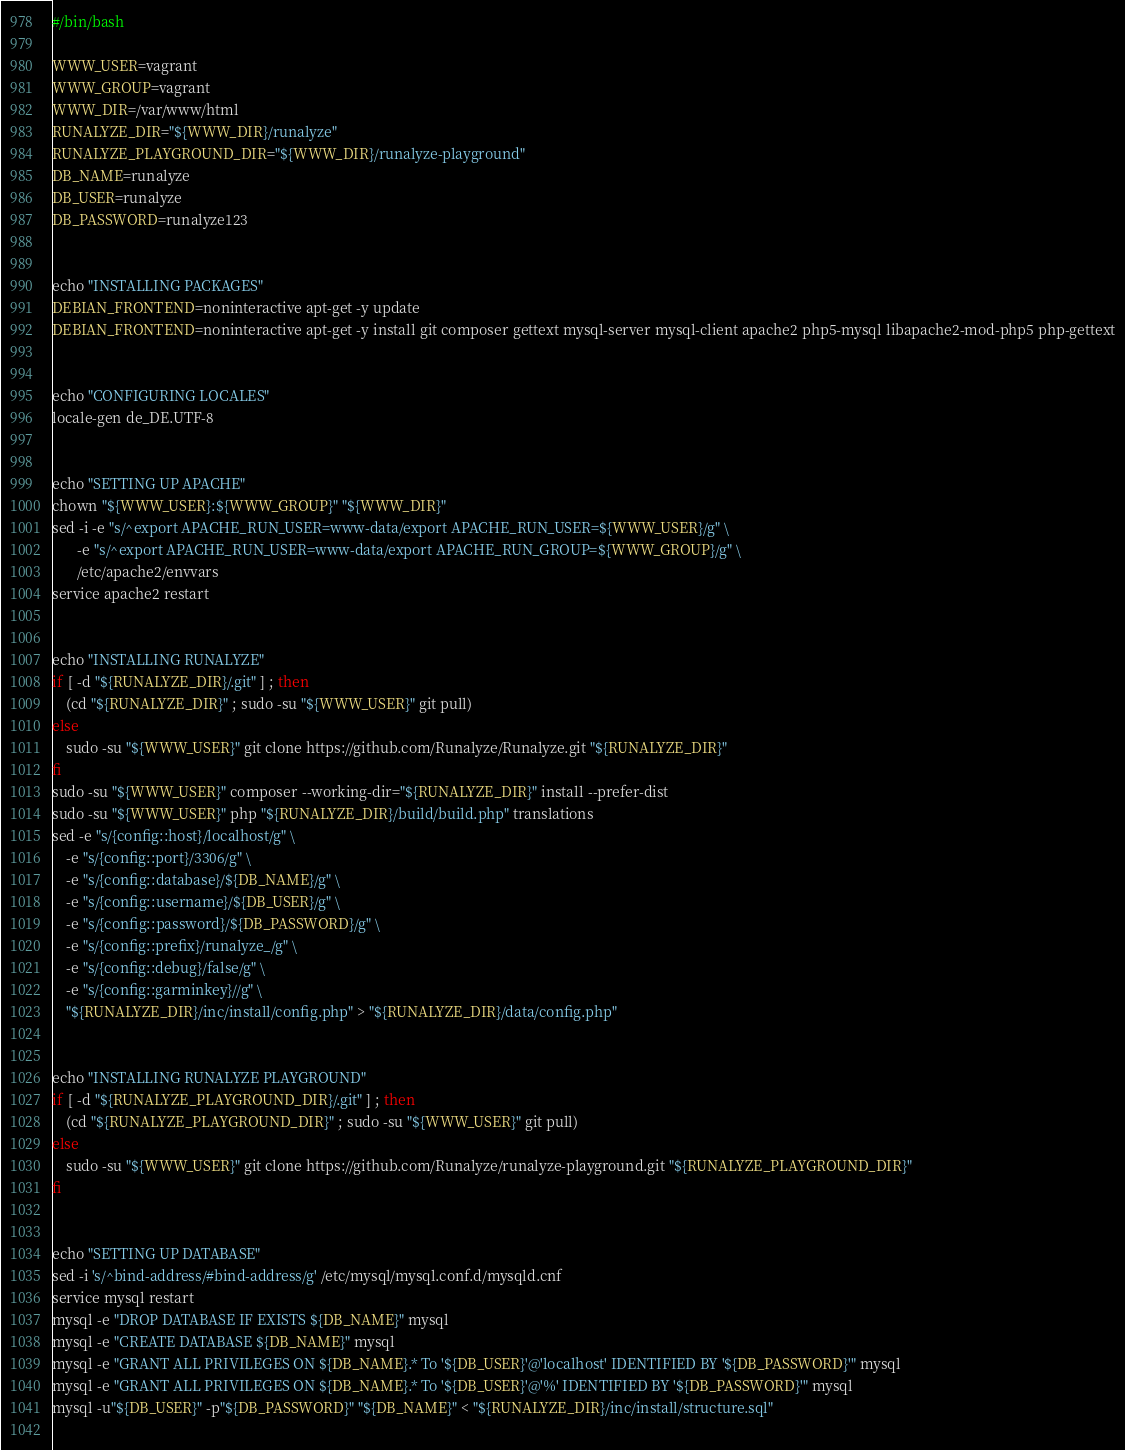<code> <loc_0><loc_0><loc_500><loc_500><_Bash_>#/bin/bash

WWW_USER=vagrant
WWW_GROUP=vagrant
WWW_DIR=/var/www/html
RUNALYZE_DIR="${WWW_DIR}/runalyze"
RUNALYZE_PLAYGROUND_DIR="${WWW_DIR}/runalyze-playground"
DB_NAME=runalyze
DB_USER=runalyze
DB_PASSWORD=runalyze123


echo "INSTALLING PACKAGES"
DEBIAN_FRONTEND=noninteractive apt-get -y update
DEBIAN_FRONTEND=noninteractive apt-get -y install git composer gettext mysql-server mysql-client apache2 php5-mysql libapache2-mod-php5 php-gettext


echo "CONFIGURING LOCALES"
locale-gen de_DE.UTF-8


echo "SETTING UP APACHE"
chown "${WWW_USER}:${WWW_GROUP}" "${WWW_DIR}"
sed -i -e "s/^export APACHE_RUN_USER=www-data/export APACHE_RUN_USER=${WWW_USER}/g" \
       -e "s/^export APACHE_RUN_USER=www-data/export APACHE_RUN_GROUP=${WWW_GROUP}/g" \
       /etc/apache2/envvars
service apache2 restart


echo "INSTALLING RUNALYZE"
if [ -d "${RUNALYZE_DIR}/.git" ] ; then
    (cd "${RUNALYZE_DIR}" ; sudo -su "${WWW_USER}" git pull)
else
    sudo -su "${WWW_USER}" git clone https://github.com/Runalyze/Runalyze.git "${RUNALYZE_DIR}"
fi
sudo -su "${WWW_USER}" composer --working-dir="${RUNALYZE_DIR}" install --prefer-dist
sudo -su "${WWW_USER}" php "${RUNALYZE_DIR}/build/build.php" translations
sed -e "s/{config::host}/localhost/g" \
    -e "s/{config::port}/3306/g" \
    -e "s/{config::database}/${DB_NAME}/g" \
    -e "s/{config::username}/${DB_USER}/g" \
    -e "s/{config::password}/${DB_PASSWORD}/g" \
    -e "s/{config::prefix}/runalyze_/g" \
    -e "s/{config::debug}/false/g" \
    -e "s/{config::garminkey}//g" \
    "${RUNALYZE_DIR}/inc/install/config.php" > "${RUNALYZE_DIR}/data/config.php"


echo "INSTALLING RUNALYZE PLAYGROUND"
if [ -d "${RUNALYZE_PLAYGROUND_DIR}/.git" ] ; then
    (cd "${RUNALYZE_PLAYGROUND_DIR}" ; sudo -su "${WWW_USER}" git pull)
else
    sudo -su "${WWW_USER}" git clone https://github.com/Runalyze/runalyze-playground.git "${RUNALYZE_PLAYGROUND_DIR}"
fi


echo "SETTING UP DATABASE"
sed -i 's/^bind-address/#bind-address/g' /etc/mysql/mysql.conf.d/mysqld.cnf
service mysql restart
mysql -e "DROP DATABASE IF EXISTS ${DB_NAME}" mysql
mysql -e "CREATE DATABASE ${DB_NAME}" mysql
mysql -e "GRANT ALL PRIVILEGES ON ${DB_NAME}.* To '${DB_USER}'@'localhost' IDENTIFIED BY '${DB_PASSWORD}'" mysql
mysql -e "GRANT ALL PRIVILEGES ON ${DB_NAME}.* To '${DB_USER}'@'%' IDENTIFIED BY '${DB_PASSWORD}'" mysql
mysql -u"${DB_USER}" -p"${DB_PASSWORD}" "${DB_NAME}" < "${RUNALYZE_DIR}/inc/install/structure.sql"
    
</code> 